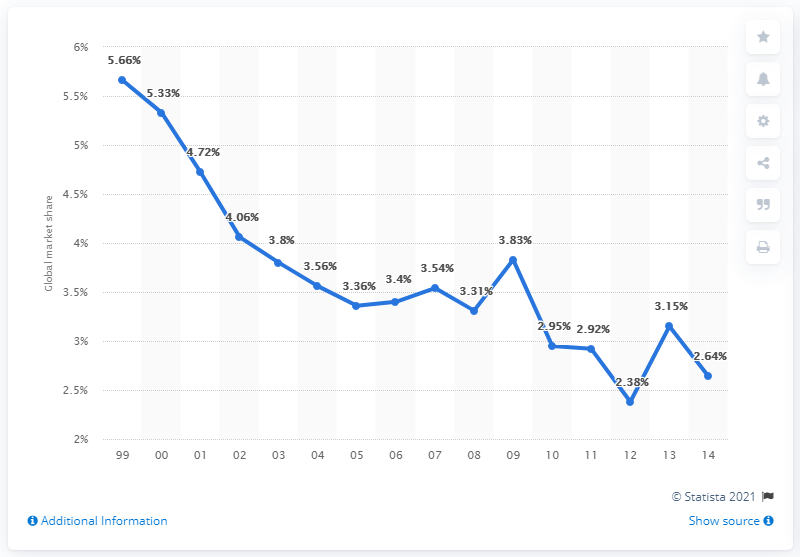Give some essential details in this illustration. In 2014, Fiat's global market share was 2.64%. 